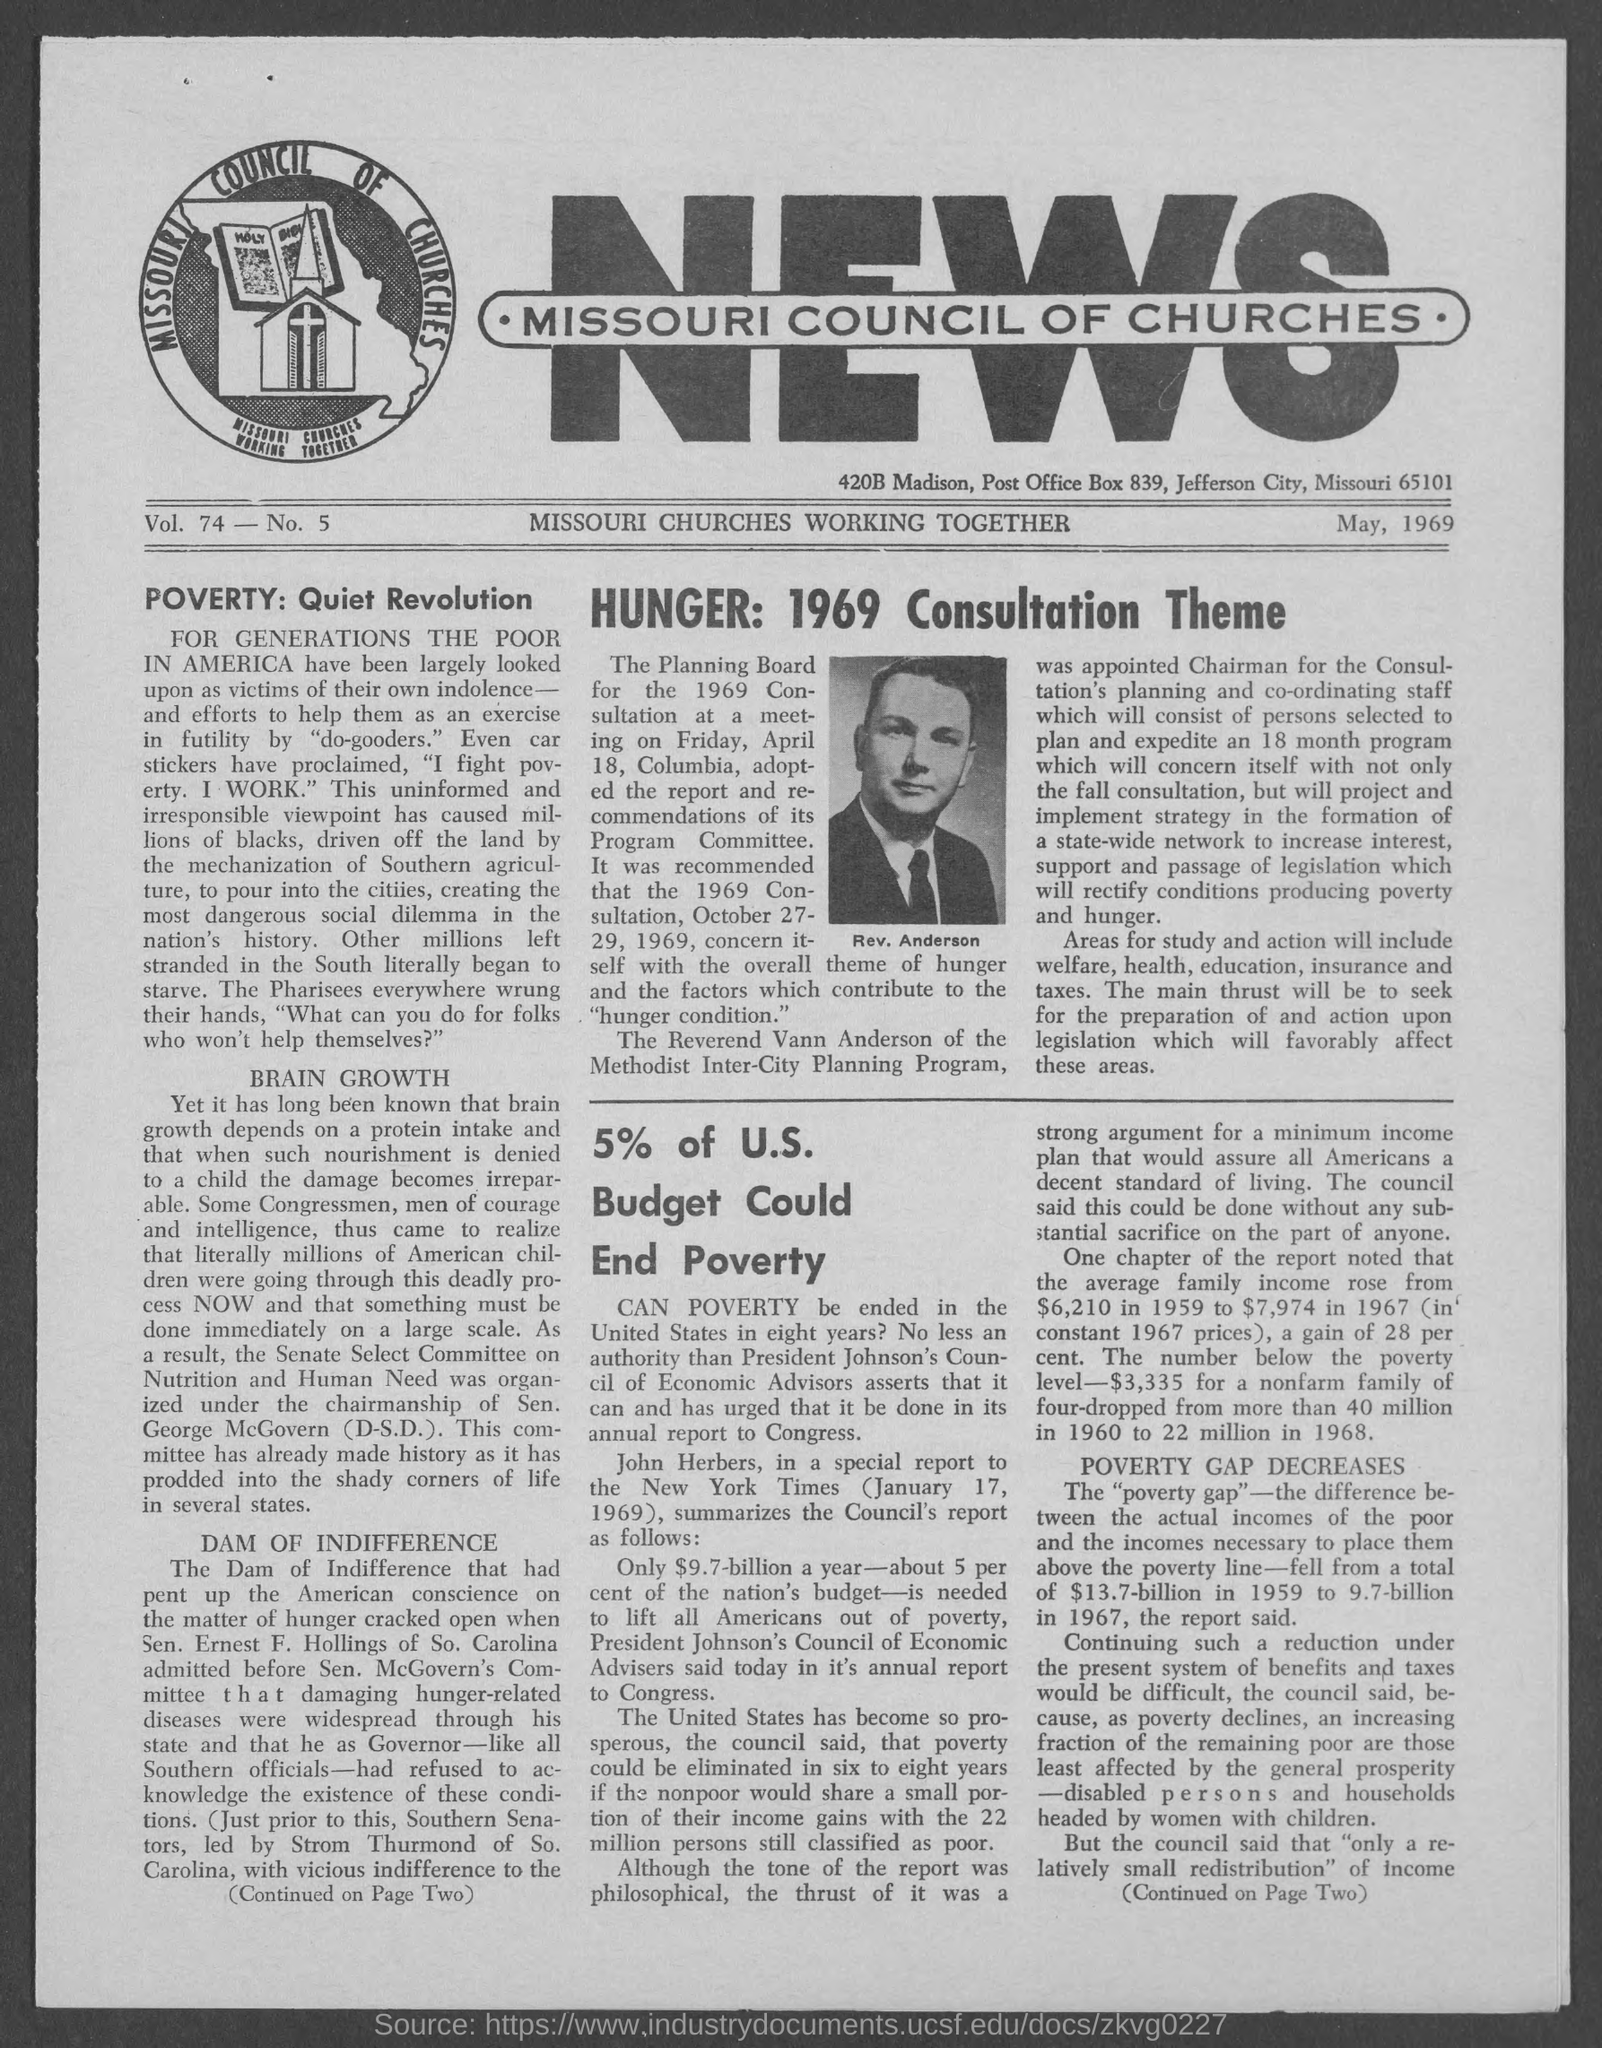What is the date on the document?
Keep it short and to the point. May, 1969. What is the Vol.?
Offer a terse response. 74. What is the No.?
Provide a succinct answer. 5. When is the Planning Board for the 1969 Consultation meeting?
Provide a succinct answer. April 18. 